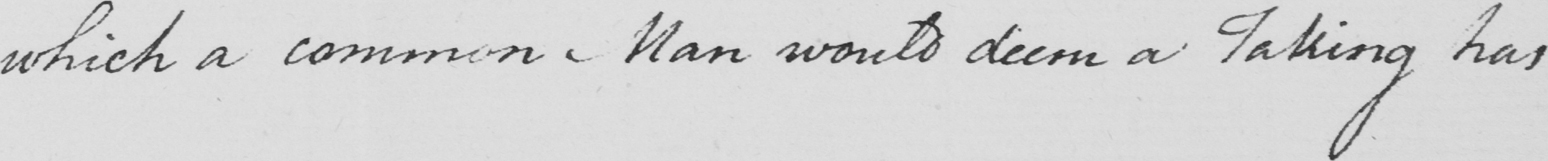Please provide the text content of this handwritten line. which a common Man would deem a taking has 